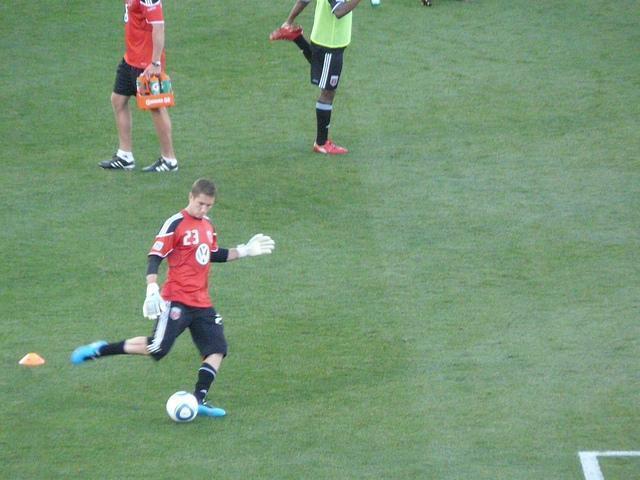How many people are in the picture?
Give a very brief answer. 3. 